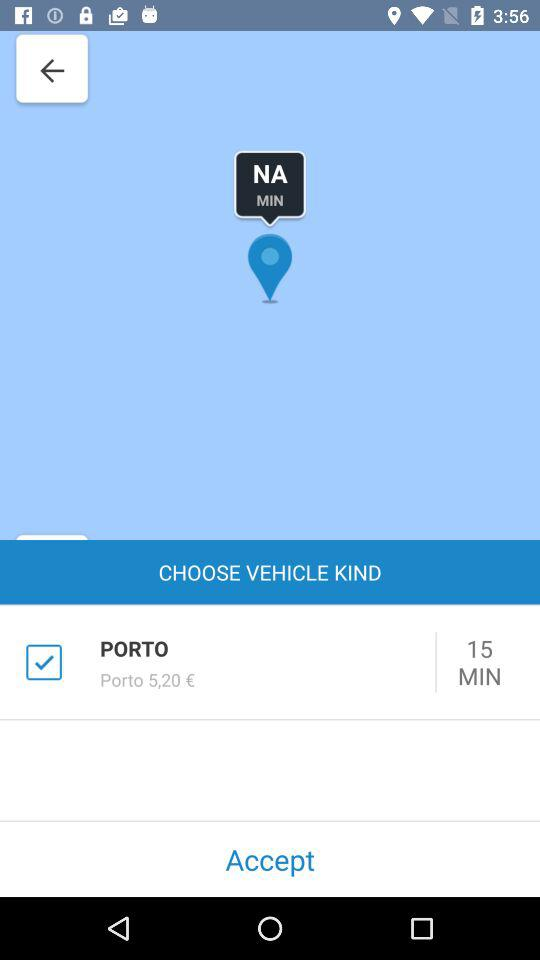How many minutes of driving does the cheapest car provide?
Answer the question using a single word or phrase. 15 